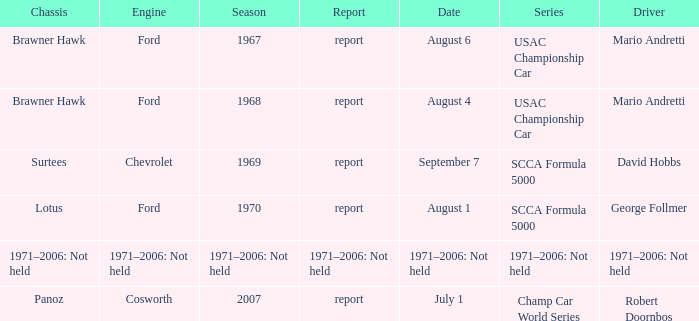Which engine is responsible for the USAC Championship Car? Ford, Ford. 